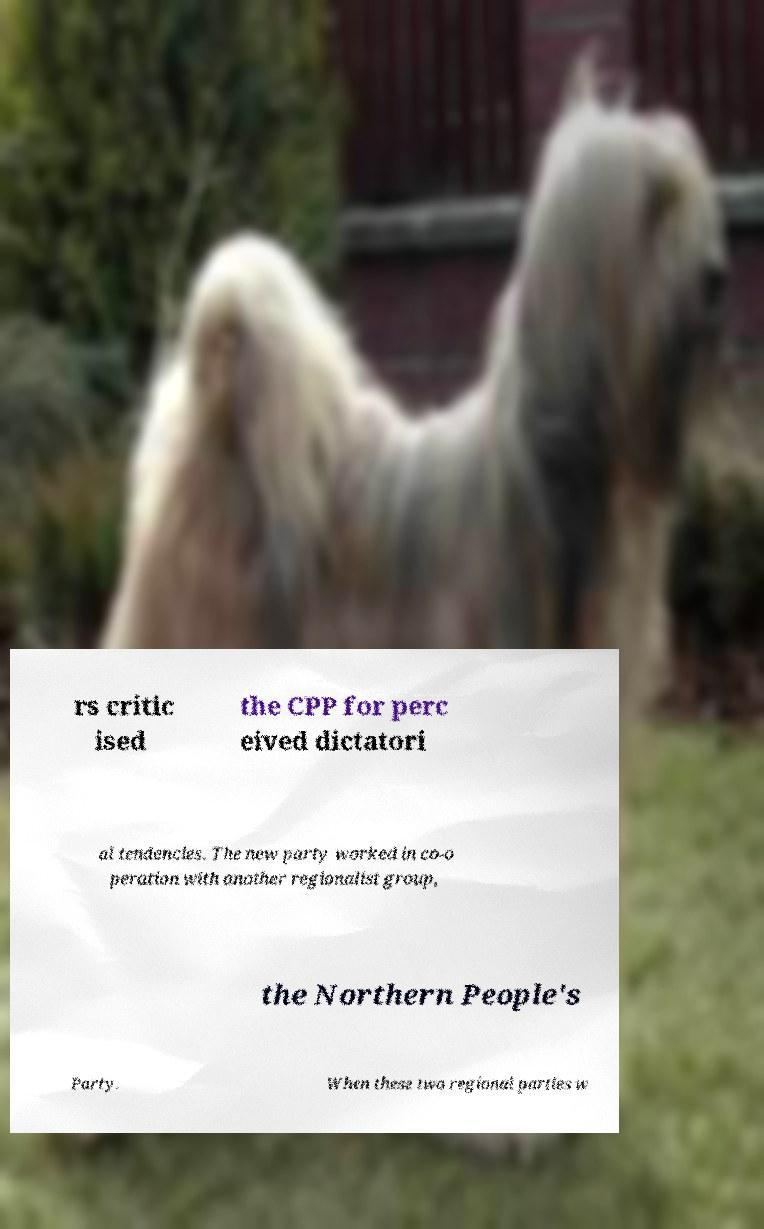There's text embedded in this image that I need extracted. Can you transcribe it verbatim? rs critic ised the CPP for perc eived dictatori al tendencies. The new party worked in co-o peration with another regionalist group, the Northern People's Party. When these two regional parties w 